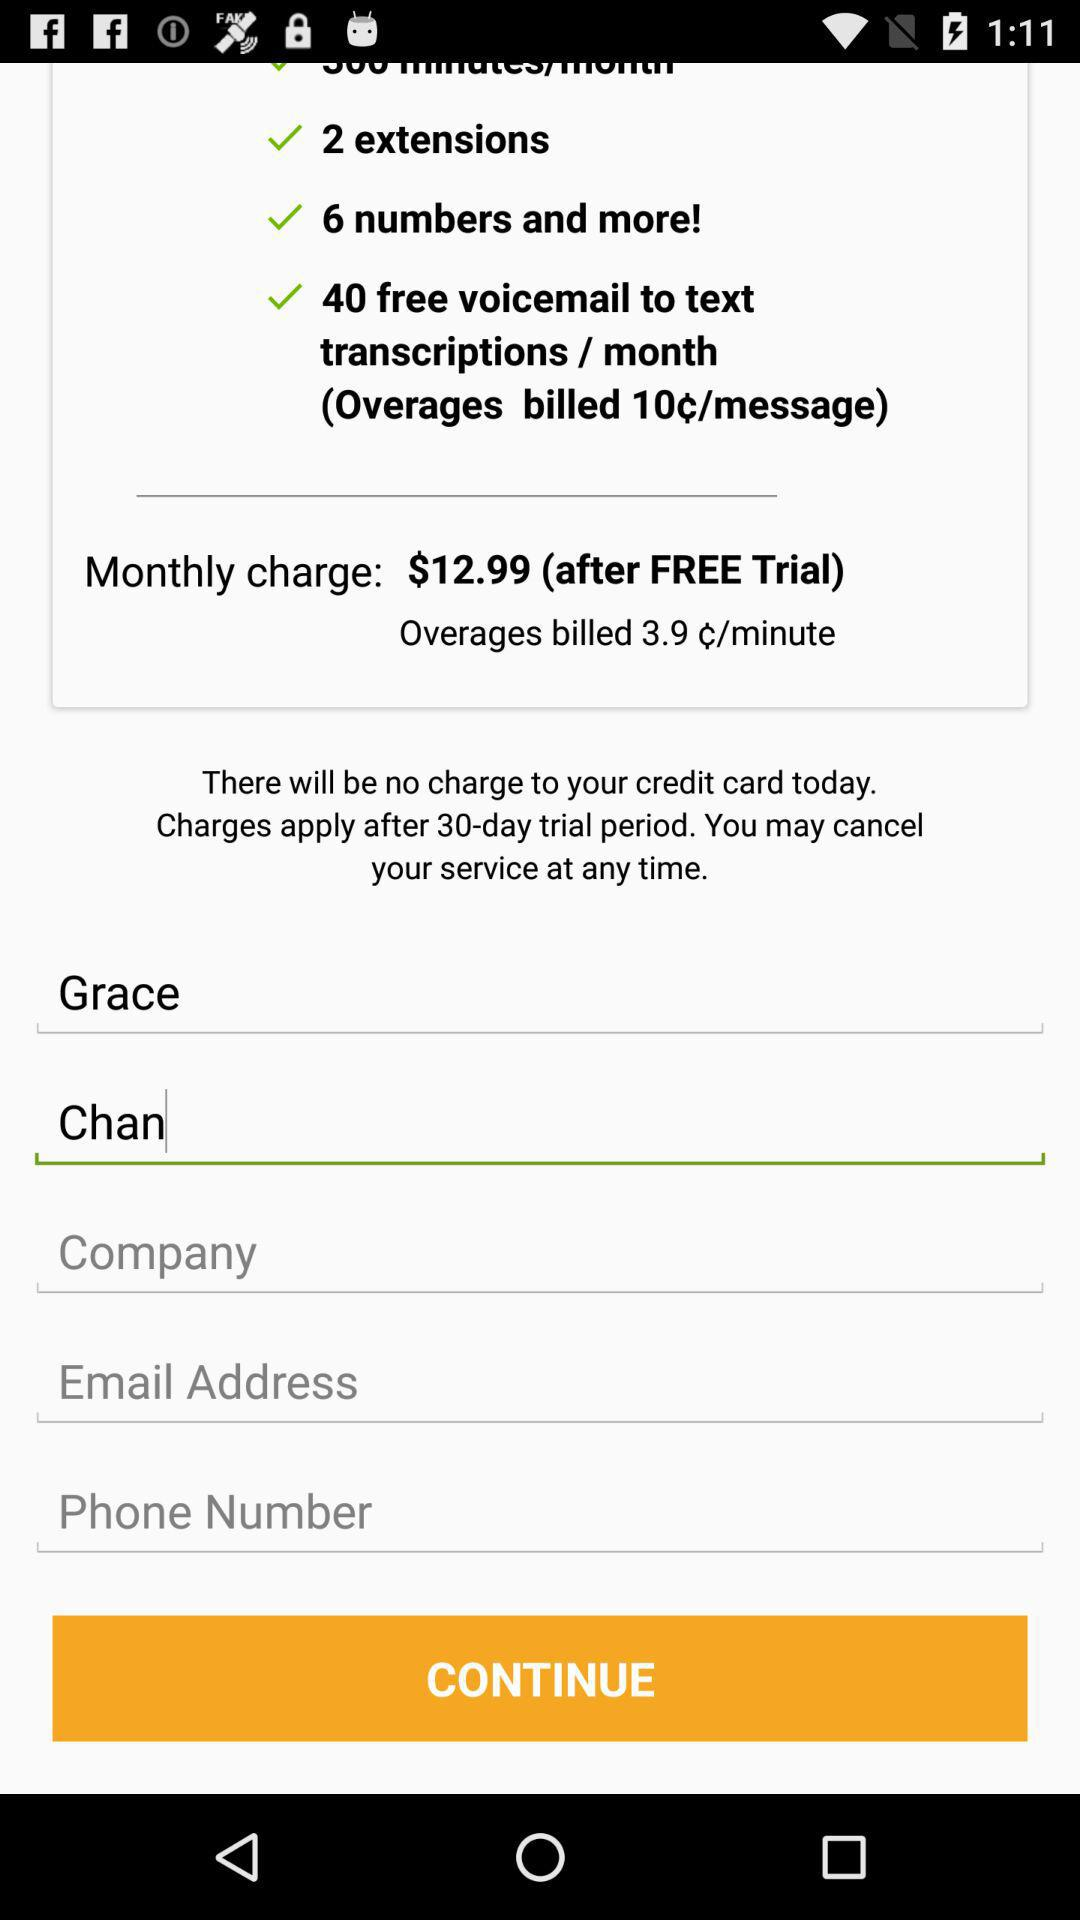What is the overage charge per minute? The overage charge per minute is 3.9 cents. 